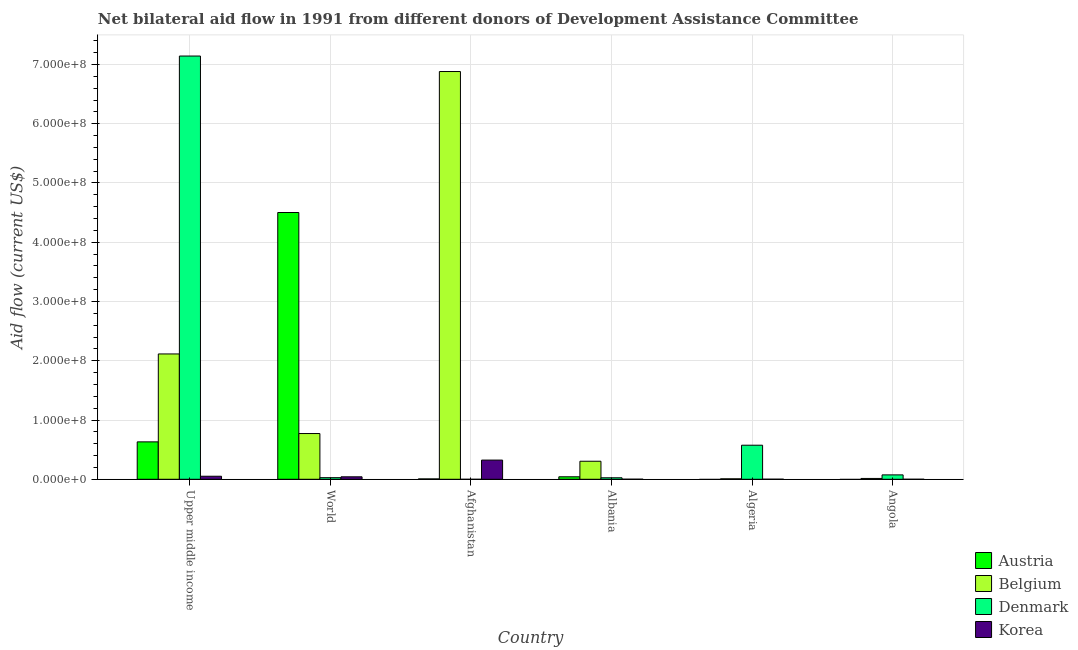How many different coloured bars are there?
Your answer should be compact. 4. How many groups of bars are there?
Give a very brief answer. 6. Are the number of bars per tick equal to the number of legend labels?
Offer a terse response. No. Are the number of bars on each tick of the X-axis equal?
Provide a short and direct response. No. What is the label of the 1st group of bars from the left?
Offer a terse response. Upper middle income. What is the amount of aid given by denmark in Upper middle income?
Give a very brief answer. 7.14e+08. Across all countries, what is the maximum amount of aid given by belgium?
Make the answer very short. 6.88e+08. What is the total amount of aid given by belgium in the graph?
Your response must be concise. 1.01e+09. What is the difference between the amount of aid given by korea in Albania and that in Upper middle income?
Provide a succinct answer. -5.00e+06. What is the difference between the amount of aid given by korea in Angola and the amount of aid given by austria in World?
Your answer should be compact. -4.50e+08. What is the average amount of aid given by austria per country?
Provide a short and direct response. 8.64e+07. What is the difference between the amount of aid given by belgium and amount of aid given by korea in Upper middle income?
Provide a short and direct response. 2.06e+08. What is the ratio of the amount of aid given by belgium in Albania to that in World?
Your answer should be very brief. 0.39. Is the amount of aid given by belgium in Afghanistan less than that in World?
Make the answer very short. No. Is the difference between the amount of aid given by belgium in Angola and World greater than the difference between the amount of aid given by denmark in Angola and World?
Give a very brief answer. No. What is the difference between the highest and the second highest amount of aid given by denmark?
Provide a short and direct response. 6.57e+08. What is the difference between the highest and the lowest amount of aid given by korea?
Provide a short and direct response. 3.24e+07. In how many countries, is the amount of aid given by denmark greater than the average amount of aid given by denmark taken over all countries?
Your answer should be compact. 1. Is it the case that in every country, the sum of the amount of aid given by korea and amount of aid given by belgium is greater than the sum of amount of aid given by denmark and amount of aid given by austria?
Provide a short and direct response. No. Is it the case that in every country, the sum of the amount of aid given by austria and amount of aid given by belgium is greater than the amount of aid given by denmark?
Offer a terse response. No. How many countries are there in the graph?
Make the answer very short. 6. What is the difference between two consecutive major ticks on the Y-axis?
Make the answer very short. 1.00e+08. Are the values on the major ticks of Y-axis written in scientific E-notation?
Keep it short and to the point. Yes. Does the graph contain any zero values?
Keep it short and to the point. Yes. Does the graph contain grids?
Provide a short and direct response. Yes. How are the legend labels stacked?
Offer a very short reply. Vertical. What is the title of the graph?
Keep it short and to the point. Net bilateral aid flow in 1991 from different donors of Development Assistance Committee. Does "Bird species" appear as one of the legend labels in the graph?
Make the answer very short. No. What is the label or title of the X-axis?
Your answer should be very brief. Country. What is the label or title of the Y-axis?
Your response must be concise. Aid flow (current US$). What is the Aid flow (current US$) in Austria in Upper middle income?
Offer a very short reply. 6.31e+07. What is the Aid flow (current US$) in Belgium in Upper middle income?
Your response must be concise. 2.11e+08. What is the Aid flow (current US$) in Denmark in Upper middle income?
Provide a short and direct response. 7.14e+08. What is the Aid flow (current US$) in Korea in Upper middle income?
Your answer should be very brief. 5.11e+06. What is the Aid flow (current US$) of Austria in World?
Provide a short and direct response. 4.50e+08. What is the Aid flow (current US$) in Belgium in World?
Keep it short and to the point. 7.72e+07. What is the Aid flow (current US$) in Denmark in World?
Give a very brief answer. 2.71e+06. What is the Aid flow (current US$) in Korea in World?
Make the answer very short. 4.16e+06. What is the Aid flow (current US$) in Austria in Afghanistan?
Give a very brief answer. 6.20e+05. What is the Aid flow (current US$) in Belgium in Afghanistan?
Provide a succinct answer. 6.88e+08. What is the Aid flow (current US$) in Denmark in Afghanistan?
Your answer should be compact. 0. What is the Aid flow (current US$) in Korea in Afghanistan?
Your response must be concise. 3.24e+07. What is the Aid flow (current US$) in Austria in Albania?
Offer a very short reply. 4.20e+06. What is the Aid flow (current US$) in Belgium in Albania?
Provide a succinct answer. 3.04e+07. What is the Aid flow (current US$) of Denmark in Albania?
Make the answer very short. 2.52e+06. What is the Aid flow (current US$) in Austria in Algeria?
Give a very brief answer. 0. What is the Aid flow (current US$) of Belgium in Algeria?
Ensure brevity in your answer.  7.70e+05. What is the Aid flow (current US$) of Denmark in Algeria?
Provide a short and direct response. 5.75e+07. What is the Aid flow (current US$) of Austria in Angola?
Your response must be concise. 0. What is the Aid flow (current US$) of Belgium in Angola?
Provide a short and direct response. 1.41e+06. What is the Aid flow (current US$) in Denmark in Angola?
Make the answer very short. 7.40e+06. Across all countries, what is the maximum Aid flow (current US$) of Austria?
Your response must be concise. 4.50e+08. Across all countries, what is the maximum Aid flow (current US$) in Belgium?
Make the answer very short. 6.88e+08. Across all countries, what is the maximum Aid flow (current US$) in Denmark?
Your answer should be very brief. 7.14e+08. Across all countries, what is the maximum Aid flow (current US$) of Korea?
Ensure brevity in your answer.  3.24e+07. Across all countries, what is the minimum Aid flow (current US$) of Austria?
Your response must be concise. 0. Across all countries, what is the minimum Aid flow (current US$) of Belgium?
Provide a succinct answer. 7.70e+05. What is the total Aid flow (current US$) of Austria in the graph?
Your answer should be very brief. 5.18e+08. What is the total Aid flow (current US$) in Belgium in the graph?
Make the answer very short. 1.01e+09. What is the total Aid flow (current US$) of Denmark in the graph?
Provide a succinct answer. 7.84e+08. What is the total Aid flow (current US$) in Korea in the graph?
Your response must be concise. 4.19e+07. What is the difference between the Aid flow (current US$) of Austria in Upper middle income and that in World?
Offer a very short reply. -3.87e+08. What is the difference between the Aid flow (current US$) in Belgium in Upper middle income and that in World?
Offer a very short reply. 1.34e+08. What is the difference between the Aid flow (current US$) of Denmark in Upper middle income and that in World?
Make the answer very short. 7.12e+08. What is the difference between the Aid flow (current US$) in Korea in Upper middle income and that in World?
Your answer should be compact. 9.50e+05. What is the difference between the Aid flow (current US$) in Austria in Upper middle income and that in Afghanistan?
Offer a very short reply. 6.25e+07. What is the difference between the Aid flow (current US$) in Belgium in Upper middle income and that in Afghanistan?
Provide a short and direct response. -4.77e+08. What is the difference between the Aid flow (current US$) of Korea in Upper middle income and that in Afghanistan?
Make the answer very short. -2.73e+07. What is the difference between the Aid flow (current US$) in Austria in Upper middle income and that in Albania?
Ensure brevity in your answer.  5.89e+07. What is the difference between the Aid flow (current US$) of Belgium in Upper middle income and that in Albania?
Provide a short and direct response. 1.81e+08. What is the difference between the Aid flow (current US$) in Denmark in Upper middle income and that in Albania?
Offer a terse response. 7.12e+08. What is the difference between the Aid flow (current US$) of Belgium in Upper middle income and that in Algeria?
Ensure brevity in your answer.  2.11e+08. What is the difference between the Aid flow (current US$) of Denmark in Upper middle income and that in Algeria?
Make the answer very short. 6.57e+08. What is the difference between the Aid flow (current US$) in Korea in Upper middle income and that in Algeria?
Make the answer very short. 5.01e+06. What is the difference between the Aid flow (current US$) of Belgium in Upper middle income and that in Angola?
Offer a very short reply. 2.10e+08. What is the difference between the Aid flow (current US$) in Denmark in Upper middle income and that in Angola?
Keep it short and to the point. 7.07e+08. What is the difference between the Aid flow (current US$) of Korea in Upper middle income and that in Angola?
Provide a short and direct response. 5.10e+06. What is the difference between the Aid flow (current US$) in Austria in World and that in Afghanistan?
Offer a very short reply. 4.50e+08. What is the difference between the Aid flow (current US$) in Belgium in World and that in Afghanistan?
Offer a very short reply. -6.11e+08. What is the difference between the Aid flow (current US$) of Korea in World and that in Afghanistan?
Your answer should be very brief. -2.82e+07. What is the difference between the Aid flow (current US$) in Austria in World and that in Albania?
Ensure brevity in your answer.  4.46e+08. What is the difference between the Aid flow (current US$) of Belgium in World and that in Albania?
Offer a very short reply. 4.68e+07. What is the difference between the Aid flow (current US$) of Denmark in World and that in Albania?
Keep it short and to the point. 1.90e+05. What is the difference between the Aid flow (current US$) in Korea in World and that in Albania?
Keep it short and to the point. 4.05e+06. What is the difference between the Aid flow (current US$) of Belgium in World and that in Algeria?
Make the answer very short. 7.64e+07. What is the difference between the Aid flow (current US$) in Denmark in World and that in Algeria?
Offer a terse response. -5.48e+07. What is the difference between the Aid flow (current US$) of Korea in World and that in Algeria?
Offer a terse response. 4.06e+06. What is the difference between the Aid flow (current US$) in Belgium in World and that in Angola?
Give a very brief answer. 7.58e+07. What is the difference between the Aid flow (current US$) in Denmark in World and that in Angola?
Make the answer very short. -4.69e+06. What is the difference between the Aid flow (current US$) in Korea in World and that in Angola?
Make the answer very short. 4.15e+06. What is the difference between the Aid flow (current US$) in Austria in Afghanistan and that in Albania?
Your answer should be compact. -3.58e+06. What is the difference between the Aid flow (current US$) of Belgium in Afghanistan and that in Albania?
Your answer should be compact. 6.58e+08. What is the difference between the Aid flow (current US$) in Korea in Afghanistan and that in Albania?
Give a very brief answer. 3.23e+07. What is the difference between the Aid flow (current US$) in Belgium in Afghanistan and that in Algeria?
Your response must be concise. 6.87e+08. What is the difference between the Aid flow (current US$) in Korea in Afghanistan and that in Algeria?
Offer a very short reply. 3.23e+07. What is the difference between the Aid flow (current US$) in Belgium in Afghanistan and that in Angola?
Offer a terse response. 6.87e+08. What is the difference between the Aid flow (current US$) of Korea in Afghanistan and that in Angola?
Ensure brevity in your answer.  3.24e+07. What is the difference between the Aid flow (current US$) in Belgium in Albania and that in Algeria?
Your response must be concise. 2.97e+07. What is the difference between the Aid flow (current US$) of Denmark in Albania and that in Algeria?
Offer a terse response. -5.50e+07. What is the difference between the Aid flow (current US$) of Belgium in Albania and that in Angola?
Offer a terse response. 2.90e+07. What is the difference between the Aid flow (current US$) in Denmark in Albania and that in Angola?
Give a very brief answer. -4.88e+06. What is the difference between the Aid flow (current US$) in Korea in Albania and that in Angola?
Give a very brief answer. 1.00e+05. What is the difference between the Aid flow (current US$) of Belgium in Algeria and that in Angola?
Your answer should be compact. -6.40e+05. What is the difference between the Aid flow (current US$) in Denmark in Algeria and that in Angola?
Your response must be concise. 5.01e+07. What is the difference between the Aid flow (current US$) in Austria in Upper middle income and the Aid flow (current US$) in Belgium in World?
Provide a short and direct response. -1.40e+07. What is the difference between the Aid flow (current US$) in Austria in Upper middle income and the Aid flow (current US$) in Denmark in World?
Provide a succinct answer. 6.04e+07. What is the difference between the Aid flow (current US$) in Austria in Upper middle income and the Aid flow (current US$) in Korea in World?
Make the answer very short. 5.90e+07. What is the difference between the Aid flow (current US$) in Belgium in Upper middle income and the Aid flow (current US$) in Denmark in World?
Ensure brevity in your answer.  2.09e+08. What is the difference between the Aid flow (current US$) in Belgium in Upper middle income and the Aid flow (current US$) in Korea in World?
Your response must be concise. 2.07e+08. What is the difference between the Aid flow (current US$) of Denmark in Upper middle income and the Aid flow (current US$) of Korea in World?
Ensure brevity in your answer.  7.10e+08. What is the difference between the Aid flow (current US$) of Austria in Upper middle income and the Aid flow (current US$) of Belgium in Afghanistan?
Keep it short and to the point. -6.25e+08. What is the difference between the Aid flow (current US$) in Austria in Upper middle income and the Aid flow (current US$) in Korea in Afghanistan?
Your response must be concise. 3.08e+07. What is the difference between the Aid flow (current US$) of Belgium in Upper middle income and the Aid flow (current US$) of Korea in Afghanistan?
Provide a short and direct response. 1.79e+08. What is the difference between the Aid flow (current US$) in Denmark in Upper middle income and the Aid flow (current US$) in Korea in Afghanistan?
Offer a terse response. 6.82e+08. What is the difference between the Aid flow (current US$) in Austria in Upper middle income and the Aid flow (current US$) in Belgium in Albania?
Ensure brevity in your answer.  3.27e+07. What is the difference between the Aid flow (current US$) of Austria in Upper middle income and the Aid flow (current US$) of Denmark in Albania?
Your answer should be compact. 6.06e+07. What is the difference between the Aid flow (current US$) of Austria in Upper middle income and the Aid flow (current US$) of Korea in Albania?
Your answer should be very brief. 6.30e+07. What is the difference between the Aid flow (current US$) of Belgium in Upper middle income and the Aid flow (current US$) of Denmark in Albania?
Provide a succinct answer. 2.09e+08. What is the difference between the Aid flow (current US$) of Belgium in Upper middle income and the Aid flow (current US$) of Korea in Albania?
Your answer should be very brief. 2.11e+08. What is the difference between the Aid flow (current US$) in Denmark in Upper middle income and the Aid flow (current US$) in Korea in Albania?
Your answer should be compact. 7.14e+08. What is the difference between the Aid flow (current US$) of Austria in Upper middle income and the Aid flow (current US$) of Belgium in Algeria?
Provide a short and direct response. 6.24e+07. What is the difference between the Aid flow (current US$) in Austria in Upper middle income and the Aid flow (current US$) in Denmark in Algeria?
Ensure brevity in your answer.  5.65e+06. What is the difference between the Aid flow (current US$) of Austria in Upper middle income and the Aid flow (current US$) of Korea in Algeria?
Provide a short and direct response. 6.30e+07. What is the difference between the Aid flow (current US$) in Belgium in Upper middle income and the Aid flow (current US$) in Denmark in Algeria?
Offer a terse response. 1.54e+08. What is the difference between the Aid flow (current US$) of Belgium in Upper middle income and the Aid flow (current US$) of Korea in Algeria?
Offer a terse response. 2.11e+08. What is the difference between the Aid flow (current US$) of Denmark in Upper middle income and the Aid flow (current US$) of Korea in Algeria?
Your answer should be very brief. 7.14e+08. What is the difference between the Aid flow (current US$) of Austria in Upper middle income and the Aid flow (current US$) of Belgium in Angola?
Keep it short and to the point. 6.17e+07. What is the difference between the Aid flow (current US$) of Austria in Upper middle income and the Aid flow (current US$) of Denmark in Angola?
Offer a very short reply. 5.57e+07. What is the difference between the Aid flow (current US$) in Austria in Upper middle income and the Aid flow (current US$) in Korea in Angola?
Offer a terse response. 6.31e+07. What is the difference between the Aid flow (current US$) in Belgium in Upper middle income and the Aid flow (current US$) in Denmark in Angola?
Make the answer very short. 2.04e+08. What is the difference between the Aid flow (current US$) in Belgium in Upper middle income and the Aid flow (current US$) in Korea in Angola?
Keep it short and to the point. 2.11e+08. What is the difference between the Aid flow (current US$) of Denmark in Upper middle income and the Aid flow (current US$) of Korea in Angola?
Provide a short and direct response. 7.14e+08. What is the difference between the Aid flow (current US$) in Austria in World and the Aid flow (current US$) in Belgium in Afghanistan?
Your answer should be compact. -2.38e+08. What is the difference between the Aid flow (current US$) of Austria in World and the Aid flow (current US$) of Korea in Afghanistan?
Your answer should be very brief. 4.18e+08. What is the difference between the Aid flow (current US$) in Belgium in World and the Aid flow (current US$) in Korea in Afghanistan?
Your answer should be compact. 4.48e+07. What is the difference between the Aid flow (current US$) in Denmark in World and the Aid flow (current US$) in Korea in Afghanistan?
Give a very brief answer. -2.97e+07. What is the difference between the Aid flow (current US$) of Austria in World and the Aid flow (current US$) of Belgium in Albania?
Your answer should be compact. 4.20e+08. What is the difference between the Aid flow (current US$) in Austria in World and the Aid flow (current US$) in Denmark in Albania?
Provide a short and direct response. 4.48e+08. What is the difference between the Aid flow (current US$) of Austria in World and the Aid flow (current US$) of Korea in Albania?
Your answer should be compact. 4.50e+08. What is the difference between the Aid flow (current US$) of Belgium in World and the Aid flow (current US$) of Denmark in Albania?
Your answer should be compact. 7.47e+07. What is the difference between the Aid flow (current US$) of Belgium in World and the Aid flow (current US$) of Korea in Albania?
Make the answer very short. 7.71e+07. What is the difference between the Aid flow (current US$) of Denmark in World and the Aid flow (current US$) of Korea in Albania?
Make the answer very short. 2.60e+06. What is the difference between the Aid flow (current US$) in Austria in World and the Aid flow (current US$) in Belgium in Algeria?
Ensure brevity in your answer.  4.49e+08. What is the difference between the Aid flow (current US$) in Austria in World and the Aid flow (current US$) in Denmark in Algeria?
Provide a succinct answer. 3.93e+08. What is the difference between the Aid flow (current US$) of Austria in World and the Aid flow (current US$) of Korea in Algeria?
Keep it short and to the point. 4.50e+08. What is the difference between the Aid flow (current US$) in Belgium in World and the Aid flow (current US$) in Denmark in Algeria?
Offer a terse response. 1.97e+07. What is the difference between the Aid flow (current US$) of Belgium in World and the Aid flow (current US$) of Korea in Algeria?
Offer a terse response. 7.71e+07. What is the difference between the Aid flow (current US$) of Denmark in World and the Aid flow (current US$) of Korea in Algeria?
Keep it short and to the point. 2.61e+06. What is the difference between the Aid flow (current US$) in Austria in World and the Aid flow (current US$) in Belgium in Angola?
Provide a short and direct response. 4.49e+08. What is the difference between the Aid flow (current US$) of Austria in World and the Aid flow (current US$) of Denmark in Angola?
Keep it short and to the point. 4.43e+08. What is the difference between the Aid flow (current US$) of Austria in World and the Aid flow (current US$) of Korea in Angola?
Ensure brevity in your answer.  4.50e+08. What is the difference between the Aid flow (current US$) of Belgium in World and the Aid flow (current US$) of Denmark in Angola?
Offer a very short reply. 6.98e+07. What is the difference between the Aid flow (current US$) of Belgium in World and the Aid flow (current US$) of Korea in Angola?
Ensure brevity in your answer.  7.72e+07. What is the difference between the Aid flow (current US$) of Denmark in World and the Aid flow (current US$) of Korea in Angola?
Make the answer very short. 2.70e+06. What is the difference between the Aid flow (current US$) of Austria in Afghanistan and the Aid flow (current US$) of Belgium in Albania?
Offer a terse response. -2.98e+07. What is the difference between the Aid flow (current US$) of Austria in Afghanistan and the Aid flow (current US$) of Denmark in Albania?
Make the answer very short. -1.90e+06. What is the difference between the Aid flow (current US$) in Austria in Afghanistan and the Aid flow (current US$) in Korea in Albania?
Give a very brief answer. 5.10e+05. What is the difference between the Aid flow (current US$) of Belgium in Afghanistan and the Aid flow (current US$) of Denmark in Albania?
Keep it short and to the point. 6.86e+08. What is the difference between the Aid flow (current US$) in Belgium in Afghanistan and the Aid flow (current US$) in Korea in Albania?
Provide a succinct answer. 6.88e+08. What is the difference between the Aid flow (current US$) in Austria in Afghanistan and the Aid flow (current US$) in Belgium in Algeria?
Provide a short and direct response. -1.50e+05. What is the difference between the Aid flow (current US$) in Austria in Afghanistan and the Aid flow (current US$) in Denmark in Algeria?
Ensure brevity in your answer.  -5.69e+07. What is the difference between the Aid flow (current US$) in Austria in Afghanistan and the Aid flow (current US$) in Korea in Algeria?
Your answer should be compact. 5.20e+05. What is the difference between the Aid flow (current US$) in Belgium in Afghanistan and the Aid flow (current US$) in Denmark in Algeria?
Provide a succinct answer. 6.31e+08. What is the difference between the Aid flow (current US$) of Belgium in Afghanistan and the Aid flow (current US$) of Korea in Algeria?
Ensure brevity in your answer.  6.88e+08. What is the difference between the Aid flow (current US$) of Austria in Afghanistan and the Aid flow (current US$) of Belgium in Angola?
Keep it short and to the point. -7.90e+05. What is the difference between the Aid flow (current US$) of Austria in Afghanistan and the Aid flow (current US$) of Denmark in Angola?
Your answer should be compact. -6.78e+06. What is the difference between the Aid flow (current US$) in Austria in Afghanistan and the Aid flow (current US$) in Korea in Angola?
Keep it short and to the point. 6.10e+05. What is the difference between the Aid flow (current US$) of Belgium in Afghanistan and the Aid flow (current US$) of Denmark in Angola?
Offer a very short reply. 6.81e+08. What is the difference between the Aid flow (current US$) of Belgium in Afghanistan and the Aid flow (current US$) of Korea in Angola?
Your response must be concise. 6.88e+08. What is the difference between the Aid flow (current US$) of Austria in Albania and the Aid flow (current US$) of Belgium in Algeria?
Your answer should be compact. 3.43e+06. What is the difference between the Aid flow (current US$) of Austria in Albania and the Aid flow (current US$) of Denmark in Algeria?
Provide a succinct answer. -5.33e+07. What is the difference between the Aid flow (current US$) of Austria in Albania and the Aid flow (current US$) of Korea in Algeria?
Ensure brevity in your answer.  4.10e+06. What is the difference between the Aid flow (current US$) of Belgium in Albania and the Aid flow (current US$) of Denmark in Algeria?
Your answer should be compact. -2.70e+07. What is the difference between the Aid flow (current US$) of Belgium in Albania and the Aid flow (current US$) of Korea in Algeria?
Provide a succinct answer. 3.03e+07. What is the difference between the Aid flow (current US$) of Denmark in Albania and the Aid flow (current US$) of Korea in Algeria?
Provide a short and direct response. 2.42e+06. What is the difference between the Aid flow (current US$) in Austria in Albania and the Aid flow (current US$) in Belgium in Angola?
Make the answer very short. 2.79e+06. What is the difference between the Aid flow (current US$) of Austria in Albania and the Aid flow (current US$) of Denmark in Angola?
Provide a succinct answer. -3.20e+06. What is the difference between the Aid flow (current US$) of Austria in Albania and the Aid flow (current US$) of Korea in Angola?
Offer a very short reply. 4.19e+06. What is the difference between the Aid flow (current US$) in Belgium in Albania and the Aid flow (current US$) in Denmark in Angola?
Your answer should be compact. 2.30e+07. What is the difference between the Aid flow (current US$) of Belgium in Albania and the Aid flow (current US$) of Korea in Angola?
Keep it short and to the point. 3.04e+07. What is the difference between the Aid flow (current US$) of Denmark in Albania and the Aid flow (current US$) of Korea in Angola?
Your answer should be very brief. 2.51e+06. What is the difference between the Aid flow (current US$) of Belgium in Algeria and the Aid flow (current US$) of Denmark in Angola?
Give a very brief answer. -6.63e+06. What is the difference between the Aid flow (current US$) in Belgium in Algeria and the Aid flow (current US$) in Korea in Angola?
Offer a terse response. 7.60e+05. What is the difference between the Aid flow (current US$) of Denmark in Algeria and the Aid flow (current US$) of Korea in Angola?
Keep it short and to the point. 5.75e+07. What is the average Aid flow (current US$) of Austria per country?
Offer a terse response. 8.64e+07. What is the average Aid flow (current US$) in Belgium per country?
Keep it short and to the point. 1.68e+08. What is the average Aid flow (current US$) in Denmark per country?
Your answer should be very brief. 1.31e+08. What is the average Aid flow (current US$) in Korea per country?
Offer a terse response. 6.98e+06. What is the difference between the Aid flow (current US$) of Austria and Aid flow (current US$) of Belgium in Upper middle income?
Your response must be concise. -1.48e+08. What is the difference between the Aid flow (current US$) in Austria and Aid flow (current US$) in Denmark in Upper middle income?
Provide a succinct answer. -6.51e+08. What is the difference between the Aid flow (current US$) in Austria and Aid flow (current US$) in Korea in Upper middle income?
Offer a very short reply. 5.80e+07. What is the difference between the Aid flow (current US$) in Belgium and Aid flow (current US$) in Denmark in Upper middle income?
Provide a succinct answer. -5.03e+08. What is the difference between the Aid flow (current US$) of Belgium and Aid flow (current US$) of Korea in Upper middle income?
Your response must be concise. 2.06e+08. What is the difference between the Aid flow (current US$) of Denmark and Aid flow (current US$) of Korea in Upper middle income?
Make the answer very short. 7.09e+08. What is the difference between the Aid flow (current US$) of Austria and Aid flow (current US$) of Belgium in World?
Your answer should be very brief. 3.73e+08. What is the difference between the Aid flow (current US$) of Austria and Aid flow (current US$) of Denmark in World?
Ensure brevity in your answer.  4.47e+08. What is the difference between the Aid flow (current US$) of Austria and Aid flow (current US$) of Korea in World?
Ensure brevity in your answer.  4.46e+08. What is the difference between the Aid flow (current US$) of Belgium and Aid flow (current US$) of Denmark in World?
Make the answer very short. 7.45e+07. What is the difference between the Aid flow (current US$) of Belgium and Aid flow (current US$) of Korea in World?
Your answer should be compact. 7.30e+07. What is the difference between the Aid flow (current US$) in Denmark and Aid flow (current US$) in Korea in World?
Your answer should be compact. -1.45e+06. What is the difference between the Aid flow (current US$) in Austria and Aid flow (current US$) in Belgium in Afghanistan?
Give a very brief answer. -6.87e+08. What is the difference between the Aid flow (current US$) in Austria and Aid flow (current US$) in Korea in Afghanistan?
Ensure brevity in your answer.  -3.18e+07. What is the difference between the Aid flow (current US$) in Belgium and Aid flow (current US$) in Korea in Afghanistan?
Your response must be concise. 6.56e+08. What is the difference between the Aid flow (current US$) in Austria and Aid flow (current US$) in Belgium in Albania?
Keep it short and to the point. -2.62e+07. What is the difference between the Aid flow (current US$) in Austria and Aid flow (current US$) in Denmark in Albania?
Make the answer very short. 1.68e+06. What is the difference between the Aid flow (current US$) of Austria and Aid flow (current US$) of Korea in Albania?
Provide a short and direct response. 4.09e+06. What is the difference between the Aid flow (current US$) of Belgium and Aid flow (current US$) of Denmark in Albania?
Your response must be concise. 2.79e+07. What is the difference between the Aid flow (current US$) of Belgium and Aid flow (current US$) of Korea in Albania?
Your answer should be very brief. 3.03e+07. What is the difference between the Aid flow (current US$) in Denmark and Aid flow (current US$) in Korea in Albania?
Ensure brevity in your answer.  2.41e+06. What is the difference between the Aid flow (current US$) of Belgium and Aid flow (current US$) of Denmark in Algeria?
Your response must be concise. -5.67e+07. What is the difference between the Aid flow (current US$) of Belgium and Aid flow (current US$) of Korea in Algeria?
Ensure brevity in your answer.  6.70e+05. What is the difference between the Aid flow (current US$) in Denmark and Aid flow (current US$) in Korea in Algeria?
Make the answer very short. 5.74e+07. What is the difference between the Aid flow (current US$) in Belgium and Aid flow (current US$) in Denmark in Angola?
Your answer should be compact. -5.99e+06. What is the difference between the Aid flow (current US$) in Belgium and Aid flow (current US$) in Korea in Angola?
Provide a short and direct response. 1.40e+06. What is the difference between the Aid flow (current US$) in Denmark and Aid flow (current US$) in Korea in Angola?
Offer a terse response. 7.39e+06. What is the ratio of the Aid flow (current US$) of Austria in Upper middle income to that in World?
Keep it short and to the point. 0.14. What is the ratio of the Aid flow (current US$) in Belgium in Upper middle income to that in World?
Keep it short and to the point. 2.74. What is the ratio of the Aid flow (current US$) of Denmark in Upper middle income to that in World?
Your response must be concise. 263.55. What is the ratio of the Aid flow (current US$) in Korea in Upper middle income to that in World?
Your response must be concise. 1.23. What is the ratio of the Aid flow (current US$) of Austria in Upper middle income to that in Afghanistan?
Ensure brevity in your answer.  101.82. What is the ratio of the Aid flow (current US$) of Belgium in Upper middle income to that in Afghanistan?
Offer a very short reply. 0.31. What is the ratio of the Aid flow (current US$) in Korea in Upper middle income to that in Afghanistan?
Your answer should be very brief. 0.16. What is the ratio of the Aid flow (current US$) in Austria in Upper middle income to that in Albania?
Your response must be concise. 15.03. What is the ratio of the Aid flow (current US$) in Belgium in Upper middle income to that in Albania?
Your answer should be very brief. 6.95. What is the ratio of the Aid flow (current US$) of Denmark in Upper middle income to that in Albania?
Give a very brief answer. 283.42. What is the ratio of the Aid flow (current US$) of Korea in Upper middle income to that in Albania?
Your answer should be compact. 46.45. What is the ratio of the Aid flow (current US$) in Belgium in Upper middle income to that in Algeria?
Give a very brief answer. 274.66. What is the ratio of the Aid flow (current US$) in Denmark in Upper middle income to that in Algeria?
Offer a terse response. 12.43. What is the ratio of the Aid flow (current US$) of Korea in Upper middle income to that in Algeria?
Provide a short and direct response. 51.1. What is the ratio of the Aid flow (current US$) of Belgium in Upper middle income to that in Angola?
Make the answer very short. 149.99. What is the ratio of the Aid flow (current US$) of Denmark in Upper middle income to that in Angola?
Offer a terse response. 96.52. What is the ratio of the Aid flow (current US$) in Korea in Upper middle income to that in Angola?
Provide a short and direct response. 511. What is the ratio of the Aid flow (current US$) in Austria in World to that in Afghanistan?
Your response must be concise. 726.11. What is the ratio of the Aid flow (current US$) of Belgium in World to that in Afghanistan?
Make the answer very short. 0.11. What is the ratio of the Aid flow (current US$) in Korea in World to that in Afghanistan?
Your response must be concise. 0.13. What is the ratio of the Aid flow (current US$) in Austria in World to that in Albania?
Provide a succinct answer. 107.19. What is the ratio of the Aid flow (current US$) in Belgium in World to that in Albania?
Give a very brief answer. 2.54. What is the ratio of the Aid flow (current US$) of Denmark in World to that in Albania?
Your answer should be compact. 1.08. What is the ratio of the Aid flow (current US$) in Korea in World to that in Albania?
Your answer should be compact. 37.82. What is the ratio of the Aid flow (current US$) in Belgium in World to that in Algeria?
Offer a terse response. 100.23. What is the ratio of the Aid flow (current US$) in Denmark in World to that in Algeria?
Provide a short and direct response. 0.05. What is the ratio of the Aid flow (current US$) in Korea in World to that in Algeria?
Provide a succinct answer. 41.6. What is the ratio of the Aid flow (current US$) in Belgium in World to that in Angola?
Make the answer very short. 54.74. What is the ratio of the Aid flow (current US$) in Denmark in World to that in Angola?
Make the answer very short. 0.37. What is the ratio of the Aid flow (current US$) of Korea in World to that in Angola?
Offer a very short reply. 416. What is the ratio of the Aid flow (current US$) of Austria in Afghanistan to that in Albania?
Keep it short and to the point. 0.15. What is the ratio of the Aid flow (current US$) of Belgium in Afghanistan to that in Albania?
Ensure brevity in your answer.  22.61. What is the ratio of the Aid flow (current US$) in Korea in Afghanistan to that in Albania?
Offer a very short reply. 294.27. What is the ratio of the Aid flow (current US$) in Belgium in Afghanistan to that in Algeria?
Your answer should be very brief. 893.62. What is the ratio of the Aid flow (current US$) of Korea in Afghanistan to that in Algeria?
Your answer should be very brief. 323.7. What is the ratio of the Aid flow (current US$) of Belgium in Afghanistan to that in Angola?
Give a very brief answer. 488.01. What is the ratio of the Aid flow (current US$) in Korea in Afghanistan to that in Angola?
Offer a terse response. 3237. What is the ratio of the Aid flow (current US$) of Belgium in Albania to that in Algeria?
Give a very brief answer. 39.52. What is the ratio of the Aid flow (current US$) in Denmark in Albania to that in Algeria?
Ensure brevity in your answer.  0.04. What is the ratio of the Aid flow (current US$) of Korea in Albania to that in Algeria?
Provide a succinct answer. 1.1. What is the ratio of the Aid flow (current US$) of Belgium in Albania to that in Angola?
Your answer should be compact. 21.58. What is the ratio of the Aid flow (current US$) in Denmark in Albania to that in Angola?
Provide a succinct answer. 0.34. What is the ratio of the Aid flow (current US$) in Belgium in Algeria to that in Angola?
Your answer should be compact. 0.55. What is the ratio of the Aid flow (current US$) of Denmark in Algeria to that in Angola?
Provide a short and direct response. 7.77. What is the ratio of the Aid flow (current US$) in Korea in Algeria to that in Angola?
Provide a succinct answer. 10. What is the difference between the highest and the second highest Aid flow (current US$) in Austria?
Your answer should be very brief. 3.87e+08. What is the difference between the highest and the second highest Aid flow (current US$) in Belgium?
Your answer should be compact. 4.77e+08. What is the difference between the highest and the second highest Aid flow (current US$) in Denmark?
Keep it short and to the point. 6.57e+08. What is the difference between the highest and the second highest Aid flow (current US$) of Korea?
Provide a succinct answer. 2.73e+07. What is the difference between the highest and the lowest Aid flow (current US$) of Austria?
Offer a very short reply. 4.50e+08. What is the difference between the highest and the lowest Aid flow (current US$) of Belgium?
Offer a terse response. 6.87e+08. What is the difference between the highest and the lowest Aid flow (current US$) in Denmark?
Your response must be concise. 7.14e+08. What is the difference between the highest and the lowest Aid flow (current US$) of Korea?
Give a very brief answer. 3.24e+07. 